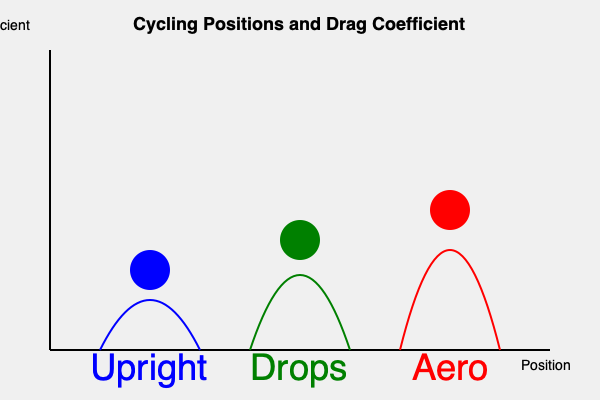Based on the graph, which cycling position is likely to have the lowest drag coefficient and why? How might this impact a triathlete's performance during the cycling leg of a race? To answer this question, we need to analyze the graph and understand the relationship between cycling positions and drag coefficient:

1. The graph shows three common cycling positions: Upright, Drops, and Aero.
2. The vertical axis represents the drag coefficient, with lower values indicating less air resistance.
3. The curves represent the approximate drag coefficient for each position.

Analyzing each position:
1. Upright position (blue): 
   - Highest curve, indicating the highest drag coefficient
   - Least aerodynamic position

2. Drops position (green):
   - Middle curve, showing a lower drag coefficient than upright
   - More aerodynamic than upright, but not optimal

3. Aero position (red):
   - Lowest curve, demonstrating the lowest drag coefficient
   - Most aerodynamic position of the three

The aero position has the lowest drag coefficient because:
- It minimizes the frontal area exposed to air resistance
- The cyclist's body is more streamlined, allowing air to flow more smoothly around them

Impact on triathlete's performance:
1. Lower drag coefficient means less energy required to maintain speed
2. Reduced air resistance allows for higher speeds with the same power output
3. Energy conservation in the cycling leg can lead to improved performance in the subsequent run

However, it's important to note that maintaining the aero position requires:
- Good flexibility and core strength
- Proper bike fit to avoid discomfort or injury
- Practice to maintain efficiency in this position

Triathletes must balance the aerodynamic benefits with comfort and sustainability over long distances.
Answer: Aero position; lowest drag coefficient due to minimized frontal area and streamlined body position, leading to reduced energy expenditure and potentially higher speeds during the cycling leg. 